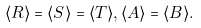<formula> <loc_0><loc_0><loc_500><loc_500>\langle R \rangle = \langle S \rangle = \langle T \rangle , \langle A \rangle = \langle B \rangle .</formula> 